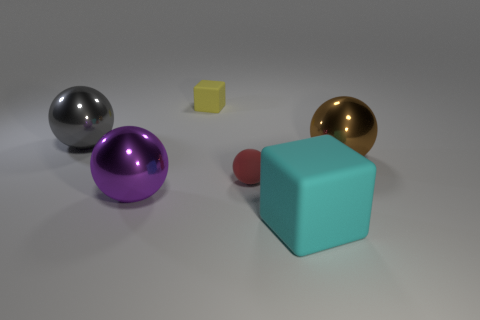Subtract all small rubber spheres. How many spheres are left? 3 Add 3 tiny red things. How many objects exist? 9 Subtract all cyan blocks. How many blocks are left? 1 Subtract 0 brown cylinders. How many objects are left? 6 Subtract all balls. How many objects are left? 2 Subtract 2 blocks. How many blocks are left? 0 Subtract all cyan balls. Subtract all cyan cylinders. How many balls are left? 4 Subtract all blue cylinders. How many brown spheres are left? 1 Subtract all large brown metal balls. Subtract all large metal things. How many objects are left? 2 Add 5 big brown spheres. How many big brown spheres are left? 6 